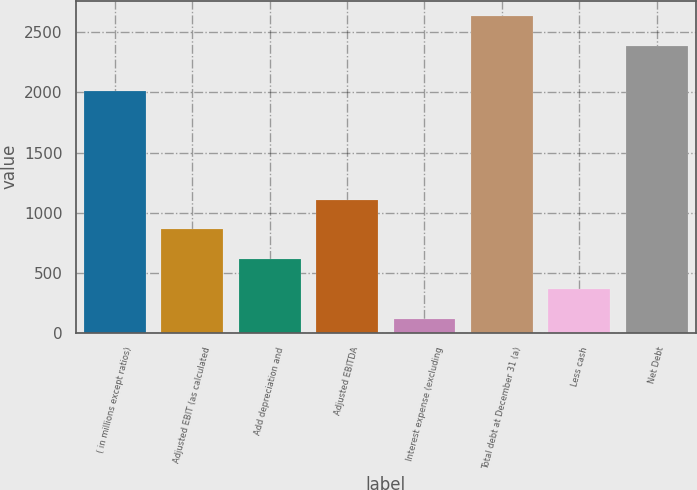<chart> <loc_0><loc_0><loc_500><loc_500><bar_chart><fcel>( in millions except ratios)<fcel>Adjusted EBIT (as calculated<fcel>Add depreciation and<fcel>Adjusted EBITDA<fcel>Interest expense (excluding<fcel>Total debt at December 31 (a)<fcel>Less cash<fcel>Net Debt<nl><fcel>2009<fcel>860.9<fcel>613<fcel>1108.8<fcel>117.2<fcel>2633.5<fcel>365.1<fcel>2385.6<nl></chart> 